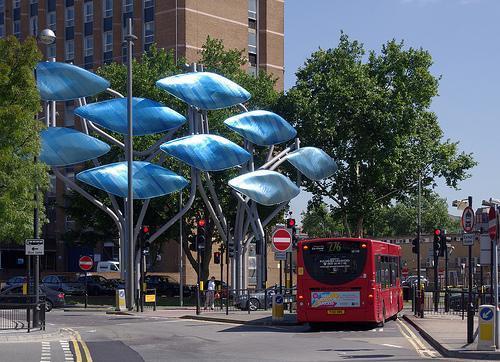How many buses are in the picture?
Give a very brief answer. 1. 